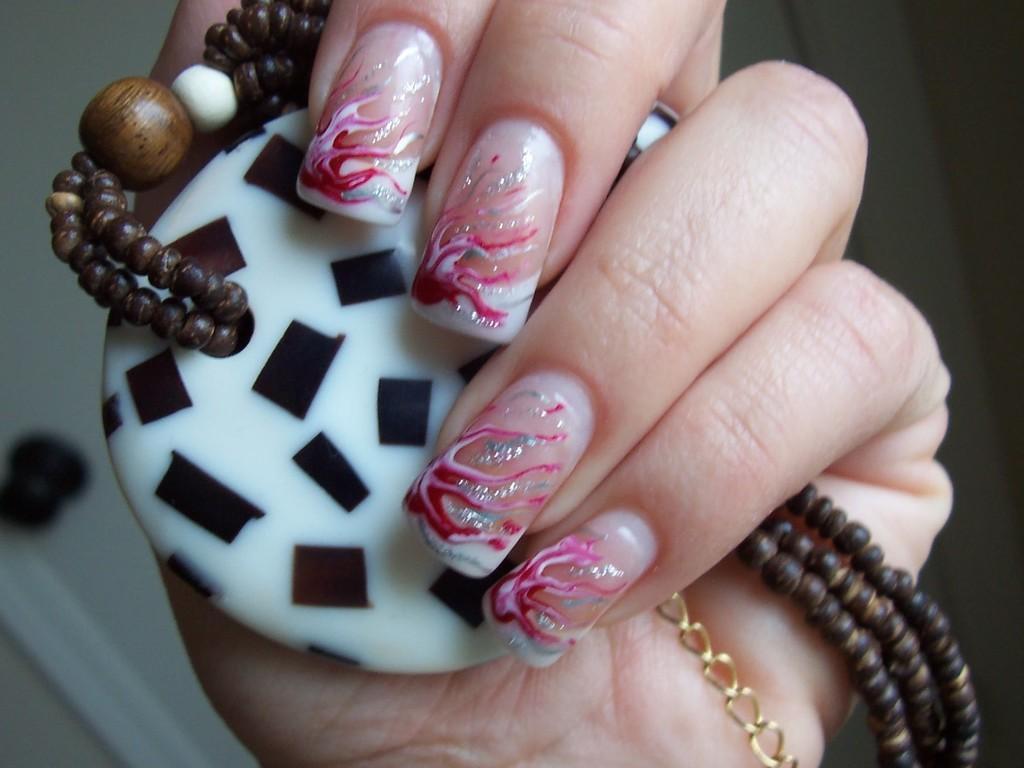Please provide a concise description of this image. This is a zoomed in picture. In the foreground we can see the hand of a person holding some objects and we can see the nail art on the nails of a person. In the background there is a white color object. 